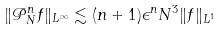Convert formula to latex. <formula><loc_0><loc_0><loc_500><loc_500>\| \mathcal { P } _ { N } ^ { n } f \| _ { L ^ { \infty } } \lesssim ( n + 1 ) \epsilon ^ { n } N ^ { 3 } \| f \| _ { L ^ { 1 } }</formula> 